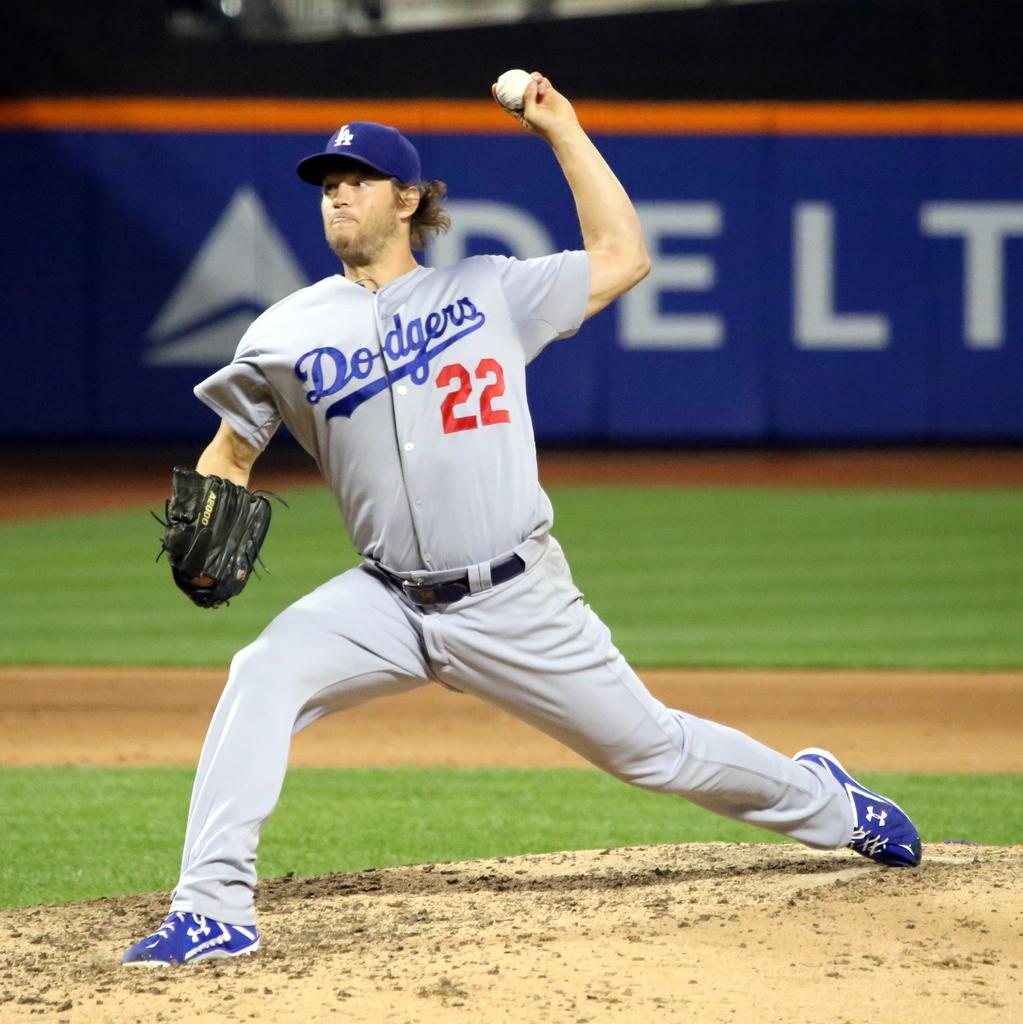What number is written below the dodgers on the jersey?
Keep it short and to the point. 22. 